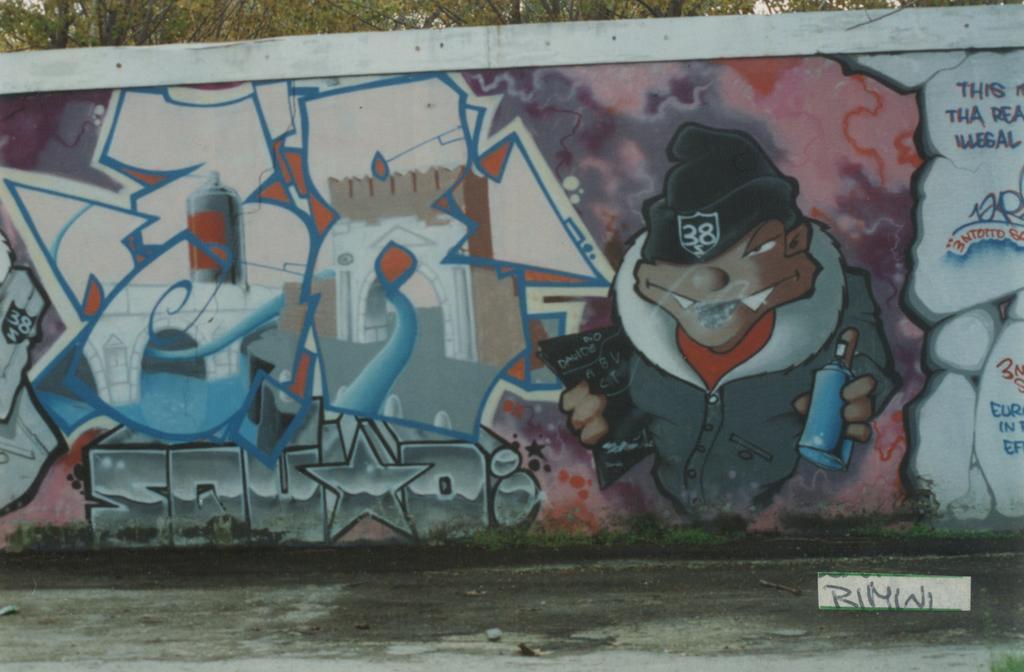Describe this image in one or two sentences. As we can see in the image there is grass, wall and trees. On wall there is painting and something written. 